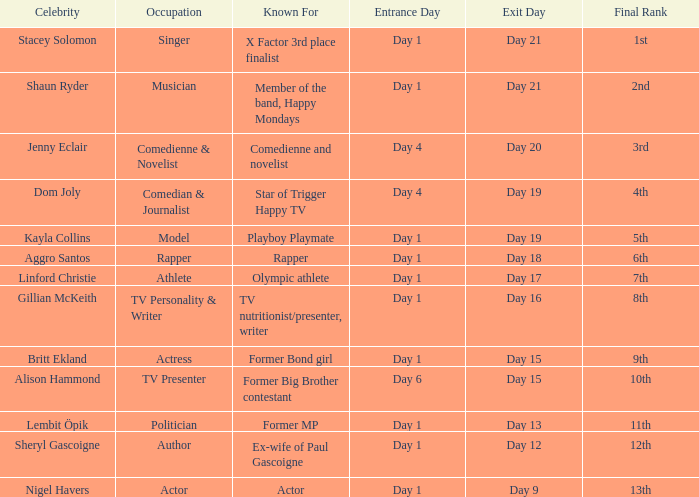In what area is dom joly well-known? Comedian, journalist and star of Trigger Happy TV. 